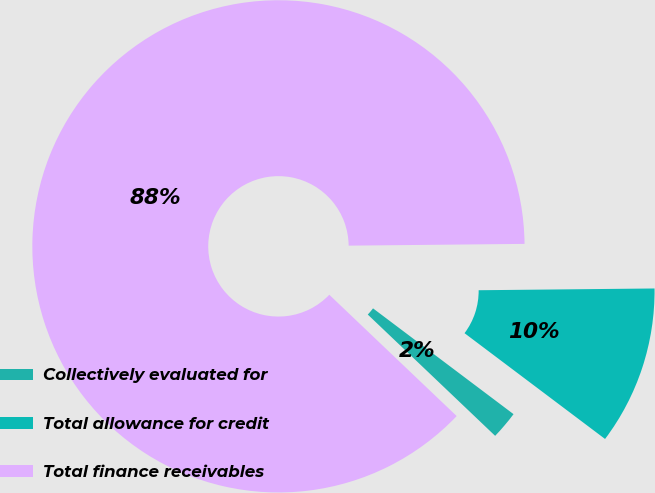<chart> <loc_0><loc_0><loc_500><loc_500><pie_chart><fcel>Collectively evaluated for<fcel>Total allowance for credit<fcel>Total finance receivables<nl><fcel>1.84%<fcel>10.43%<fcel>87.73%<nl></chart> 